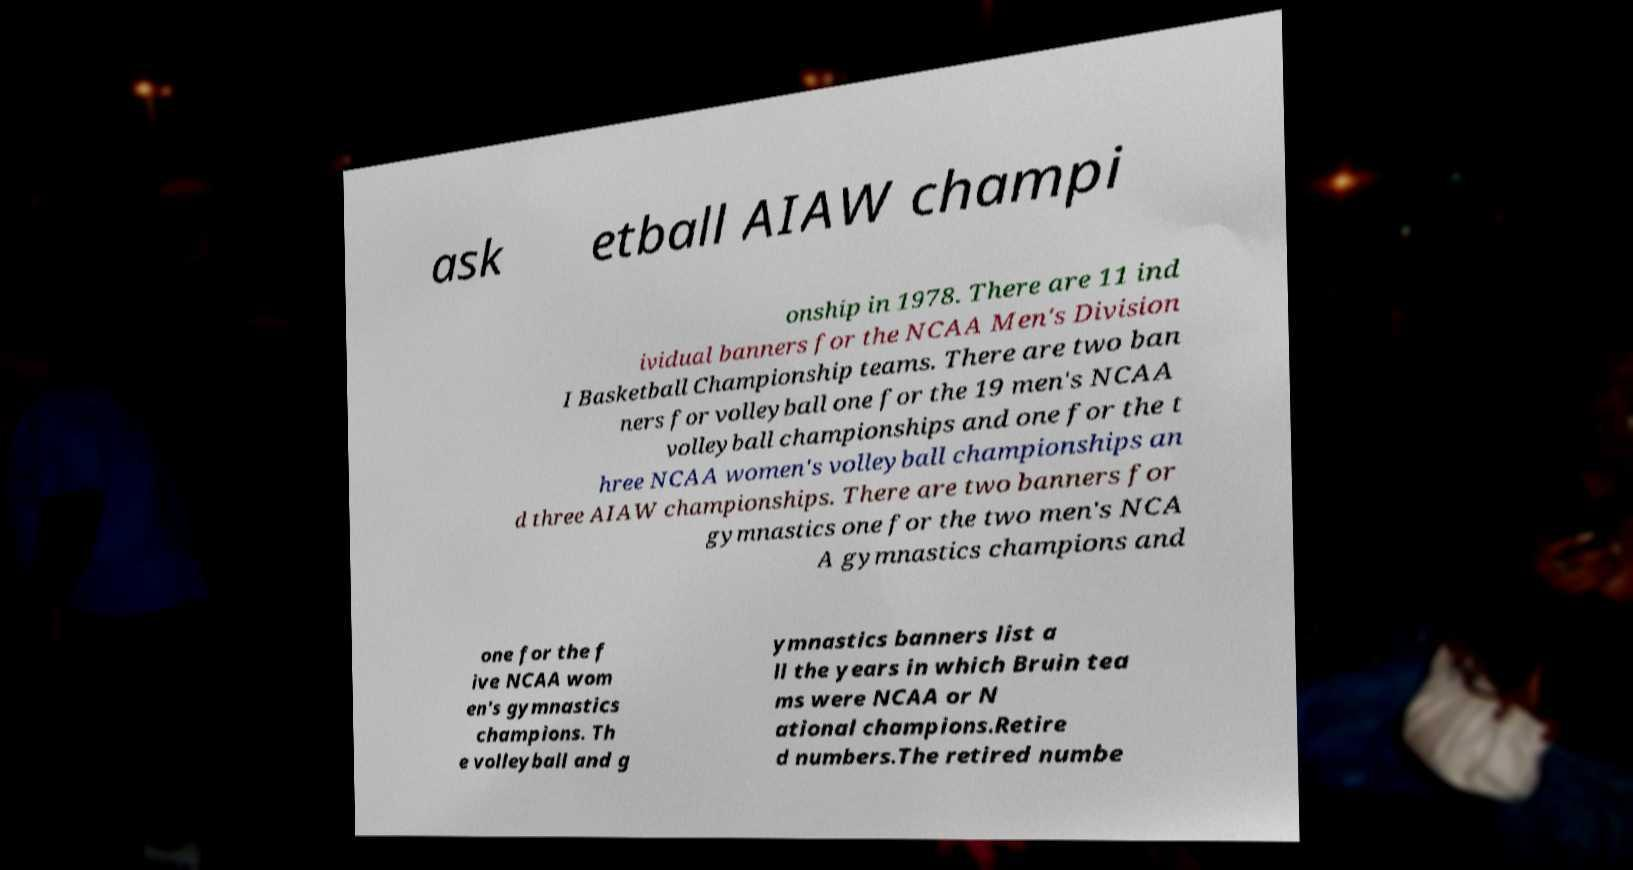Could you extract and type out the text from this image? ask etball AIAW champi onship in 1978. There are 11 ind ividual banners for the NCAA Men's Division I Basketball Championship teams. There are two ban ners for volleyball one for the 19 men's NCAA volleyball championships and one for the t hree NCAA women's volleyball championships an d three AIAW championships. There are two banners for gymnastics one for the two men's NCA A gymnastics champions and one for the f ive NCAA wom en's gymnastics champions. Th e volleyball and g ymnastics banners list a ll the years in which Bruin tea ms were NCAA or N ational champions.Retire d numbers.The retired numbe 